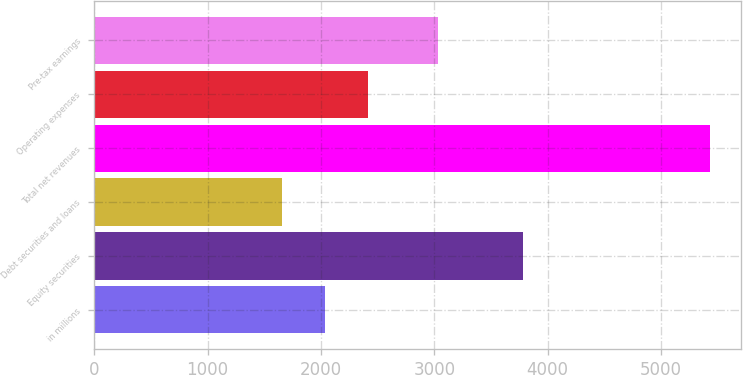<chart> <loc_0><loc_0><loc_500><loc_500><bar_chart><fcel>in millions<fcel>Equity securities<fcel>Debt securities and loans<fcel>Total net revenues<fcel>Operating expenses<fcel>Pre-tax earnings<nl><fcel>2033.1<fcel>3781<fcel>1655<fcel>5436<fcel>2411.2<fcel>3034<nl></chart> 